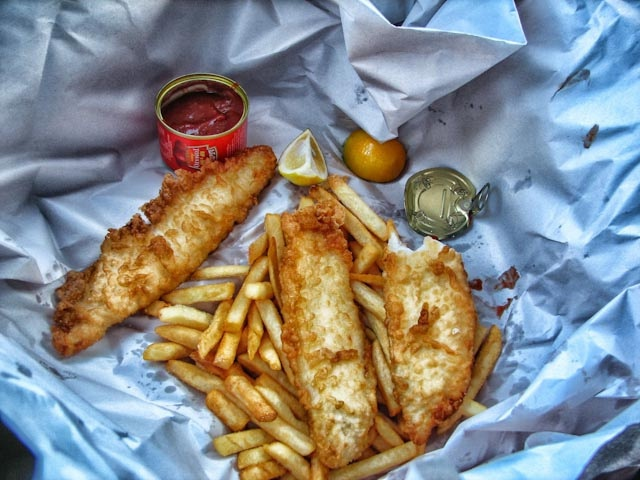Describe the objects in this image and their specific colors. I can see orange in darkblue, olive, maroon, and orange tones and orange in darkblue, darkgray, tan, lightgray, and beige tones in this image. 